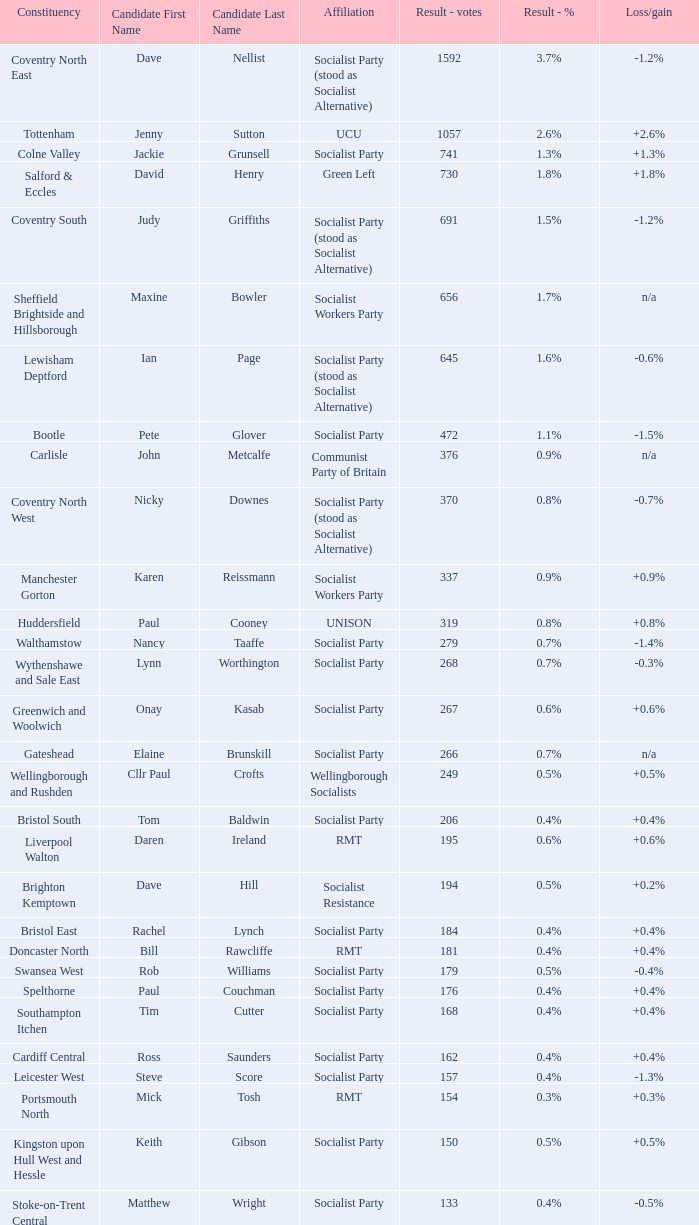What is every affiliation for candidate Daren Ireland? RMT. 